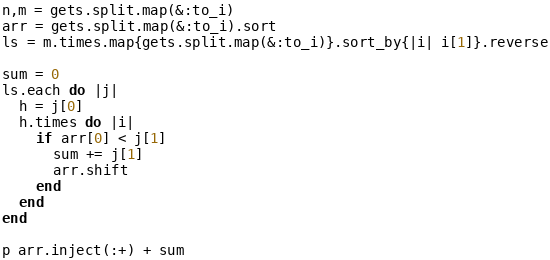Convert code to text. <code><loc_0><loc_0><loc_500><loc_500><_Ruby_>n,m = gets.split.map(&:to_i)
arr = gets.split.map(&:to_i).sort
ls = m.times.map{gets.split.map(&:to_i)}.sort_by{|i| i[1]}.reverse

sum = 0
ls.each do |j|
  h = j[0]
  h.times do |i|
    if arr[0] < j[1]
      sum += j[1]
      arr.shift
    end
  end
end

p arr.inject(:+) + sum</code> 